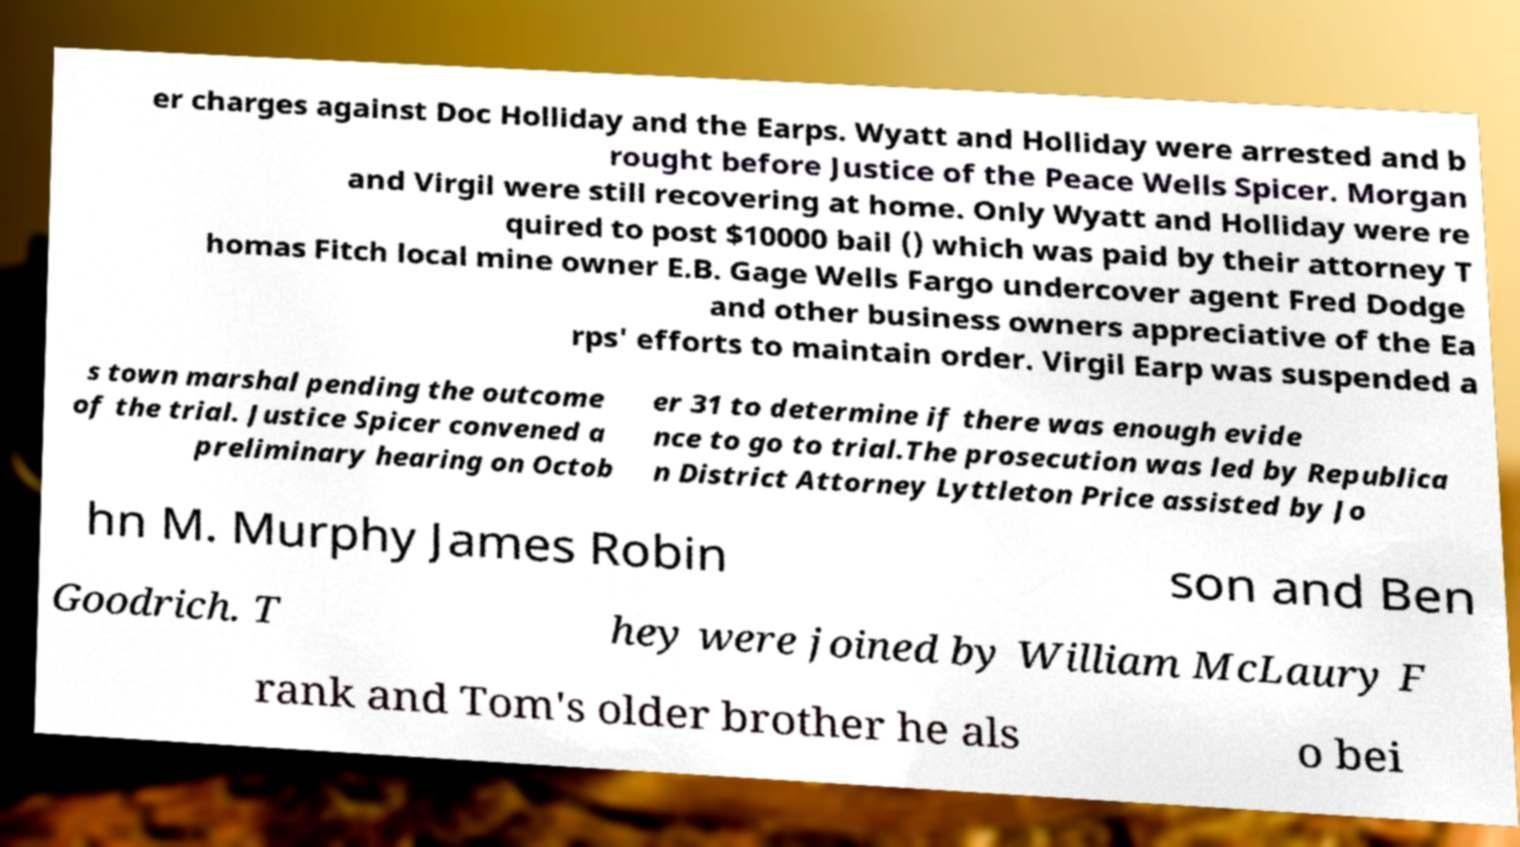For documentation purposes, I need the text within this image transcribed. Could you provide that? er charges against Doc Holliday and the Earps. Wyatt and Holliday were arrested and b rought before Justice of the Peace Wells Spicer. Morgan and Virgil were still recovering at home. Only Wyatt and Holliday were re quired to post $10000 bail () which was paid by their attorney T homas Fitch local mine owner E.B. Gage Wells Fargo undercover agent Fred Dodge and other business owners appreciative of the Ea rps' efforts to maintain order. Virgil Earp was suspended a s town marshal pending the outcome of the trial. Justice Spicer convened a preliminary hearing on Octob er 31 to determine if there was enough evide nce to go to trial.The prosecution was led by Republica n District Attorney Lyttleton Price assisted by Jo hn M. Murphy James Robin son and Ben Goodrich. T hey were joined by William McLaury F rank and Tom's older brother he als o bei 